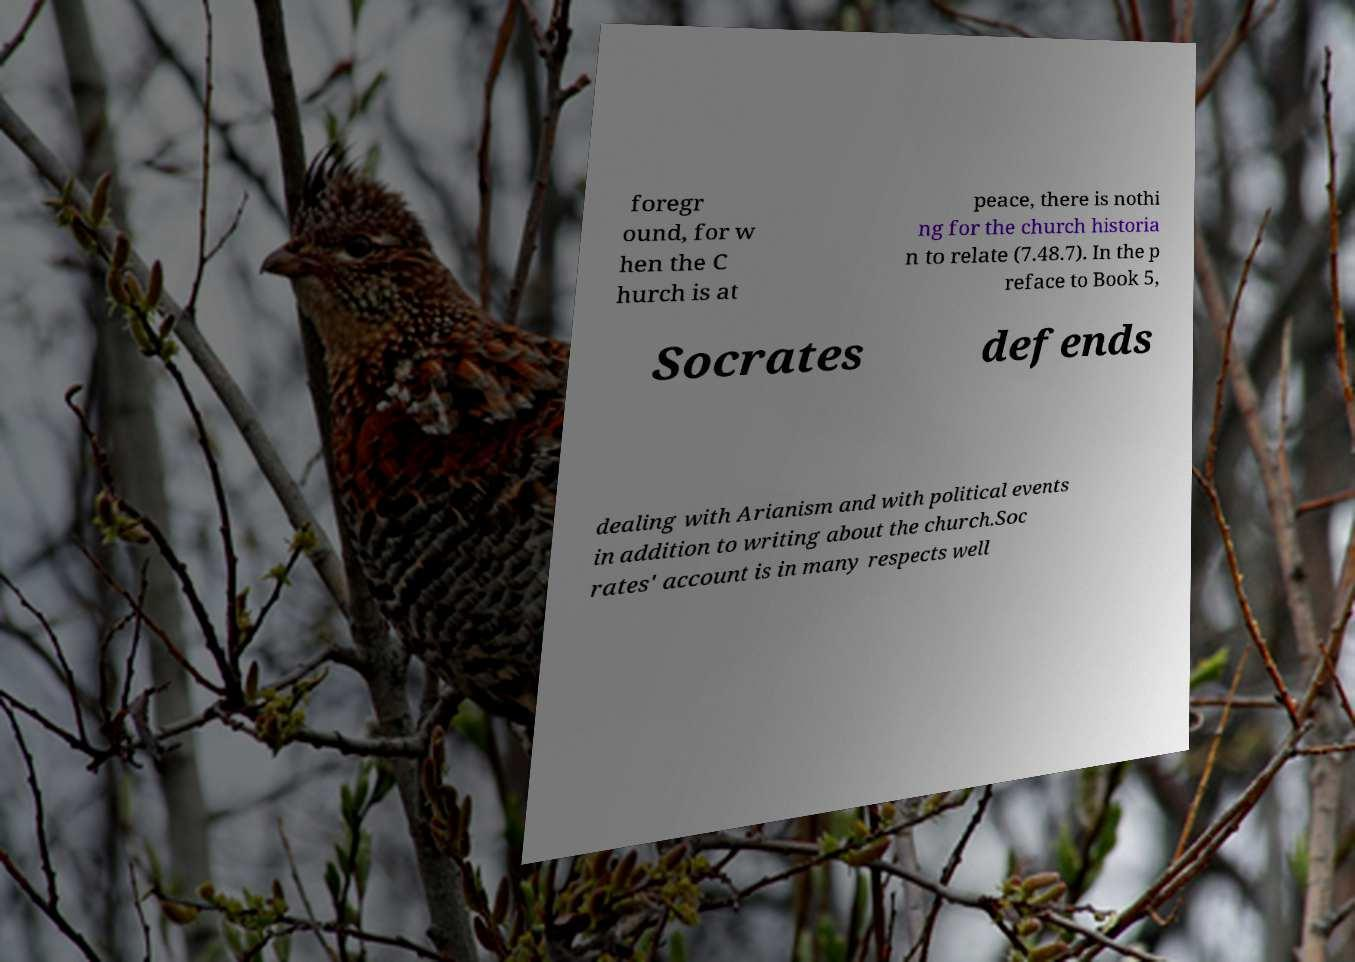Please read and relay the text visible in this image. What does it say? foregr ound, for w hen the C hurch is at peace, there is nothi ng for the church historia n to relate (7.48.7). In the p reface to Book 5, Socrates defends dealing with Arianism and with political events in addition to writing about the church.Soc rates' account is in many respects well 